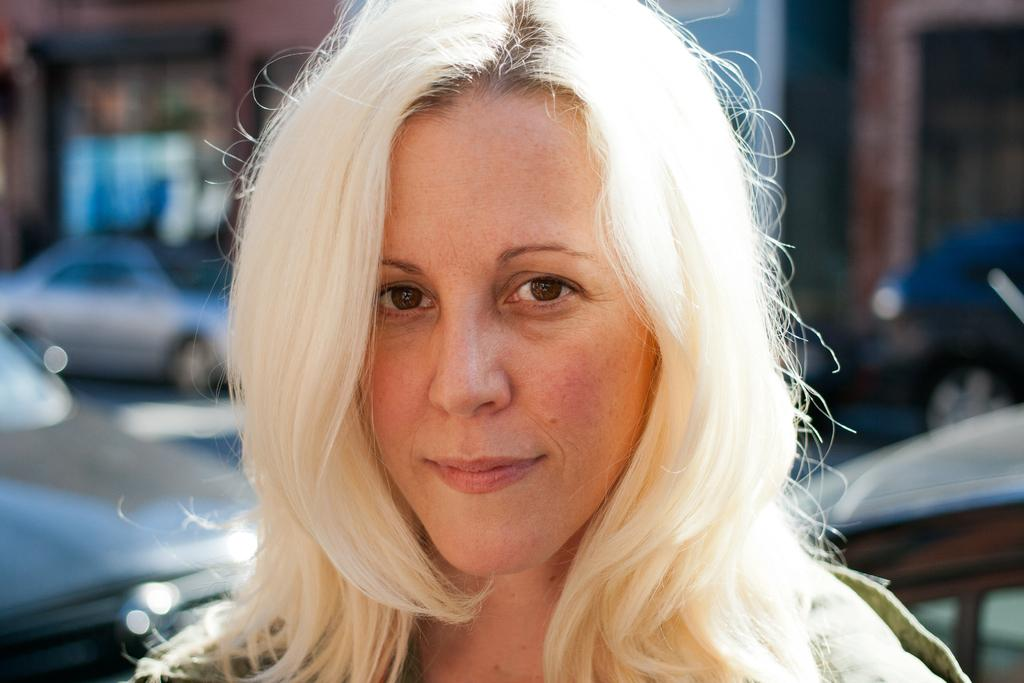Who or what is the main subject of the image? There is a person in the image. What can be seen in the distance behind the person? There are vehicles and a building in the background of the image. How would you describe the appearance of the background? The background appears blurred. Can you see a family of geese walking towards the person in the image? There is no family of geese or any geese present in the image. What type of drum is being played by the person in the image? There is no drum visible in the image; the person is not playing any musical instrument. 